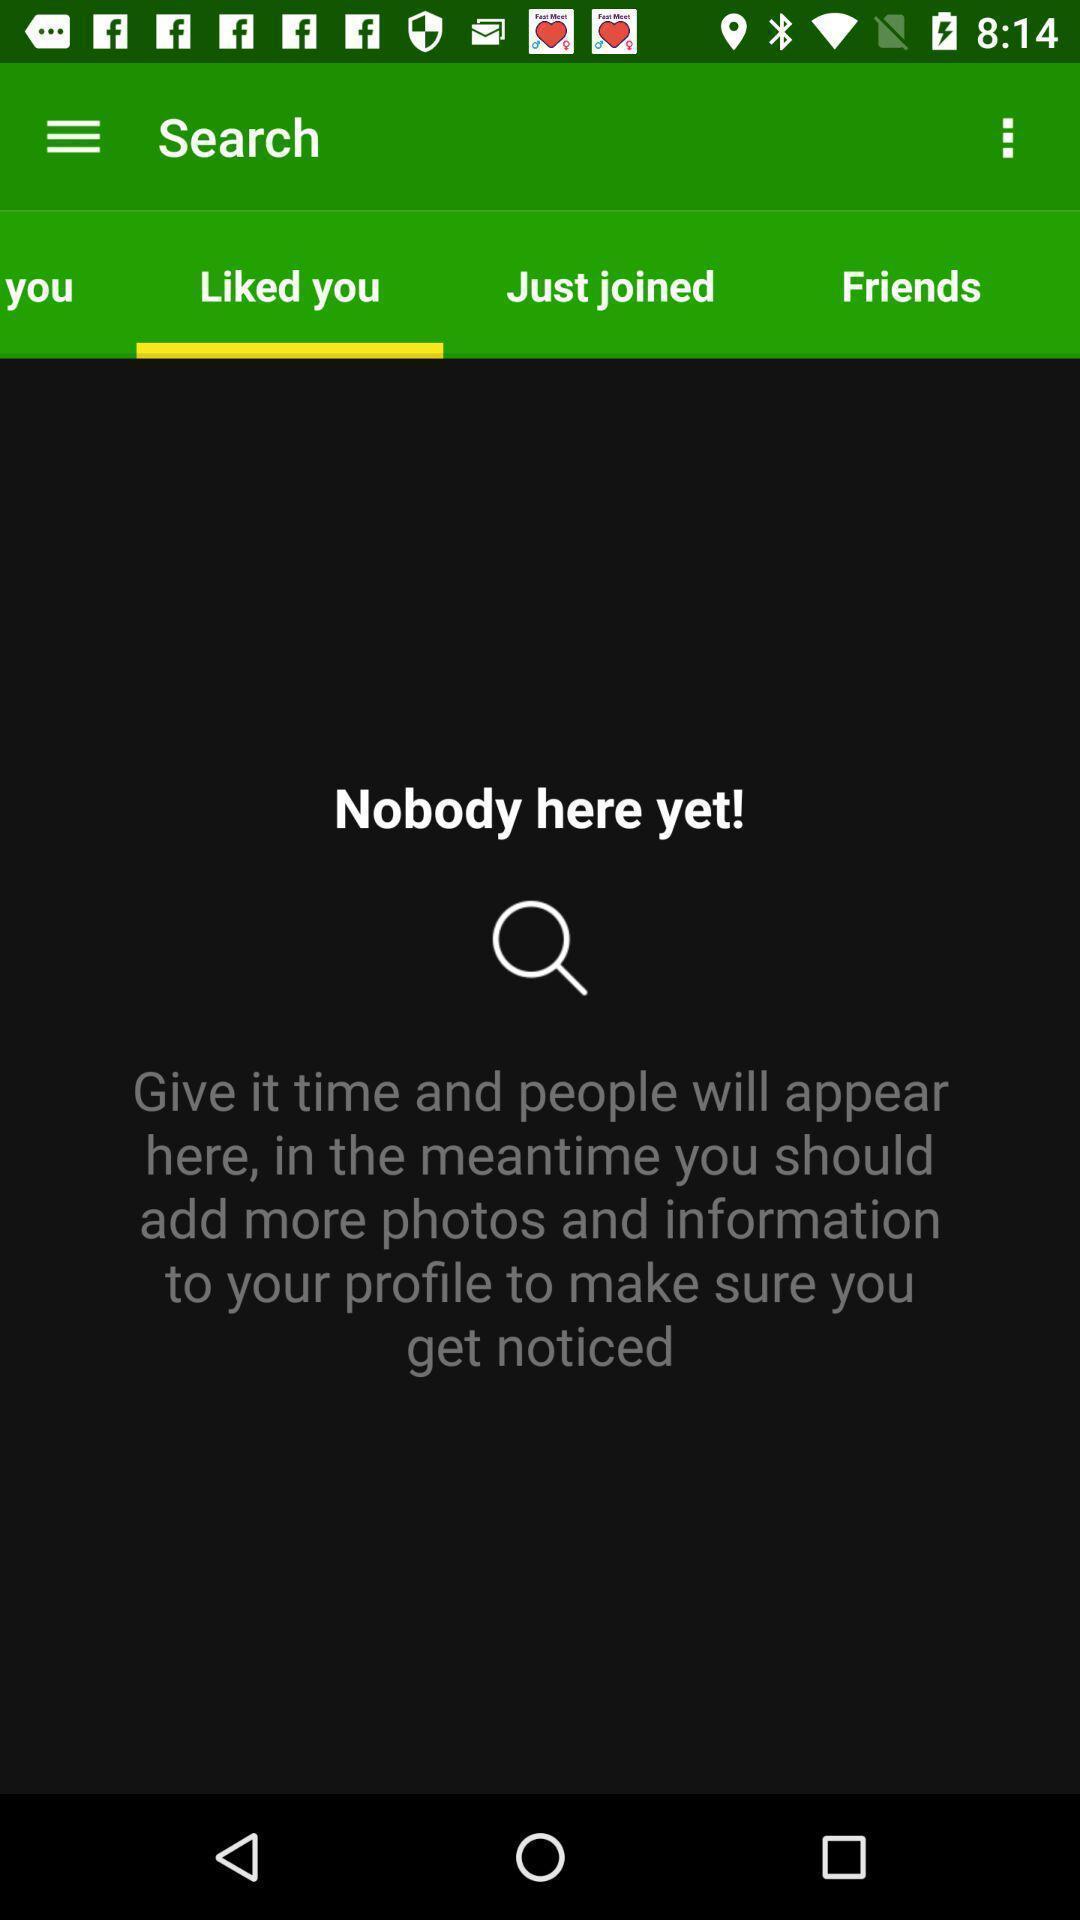What details can you identify in this image? Social app for doing search. 